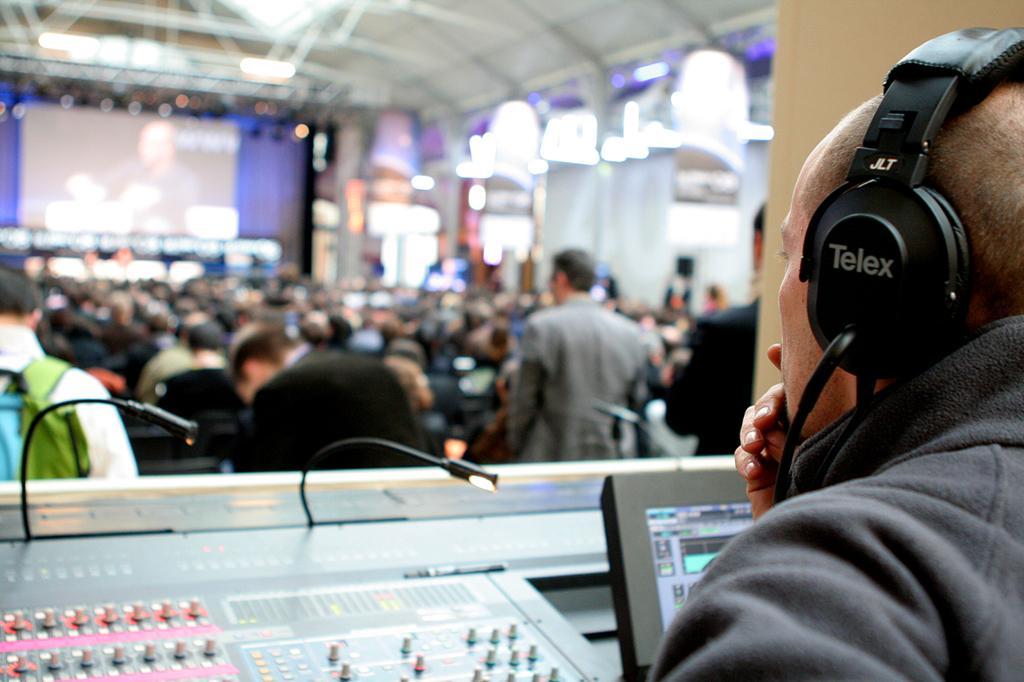Describe this image in one or two sentences. In front of the image there is a person wearing headphones, in front of the person there are two mics and there is some electronic equipment, in front of the person there are a few other people, in front of them there is a screen, behind the screen there is a curtain, on the right side of the image there are curtains, at the top of the image there are lamps and there is a rooftop supported by metal rods. 